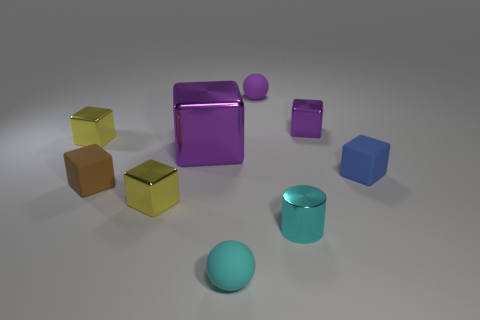Subtract all small matte blocks. How many blocks are left? 4 Subtract all yellow cubes. How many cubes are left? 4 Subtract all cyan blocks. Subtract all green spheres. How many blocks are left? 6 Add 1 matte objects. How many objects exist? 10 Subtract all balls. How many objects are left? 7 Subtract all tiny rubber things. Subtract all large purple shiny objects. How many objects are left? 4 Add 2 yellow objects. How many yellow objects are left? 4 Add 2 purple rubber spheres. How many purple rubber spheres exist? 3 Subtract 0 gray cylinders. How many objects are left? 9 